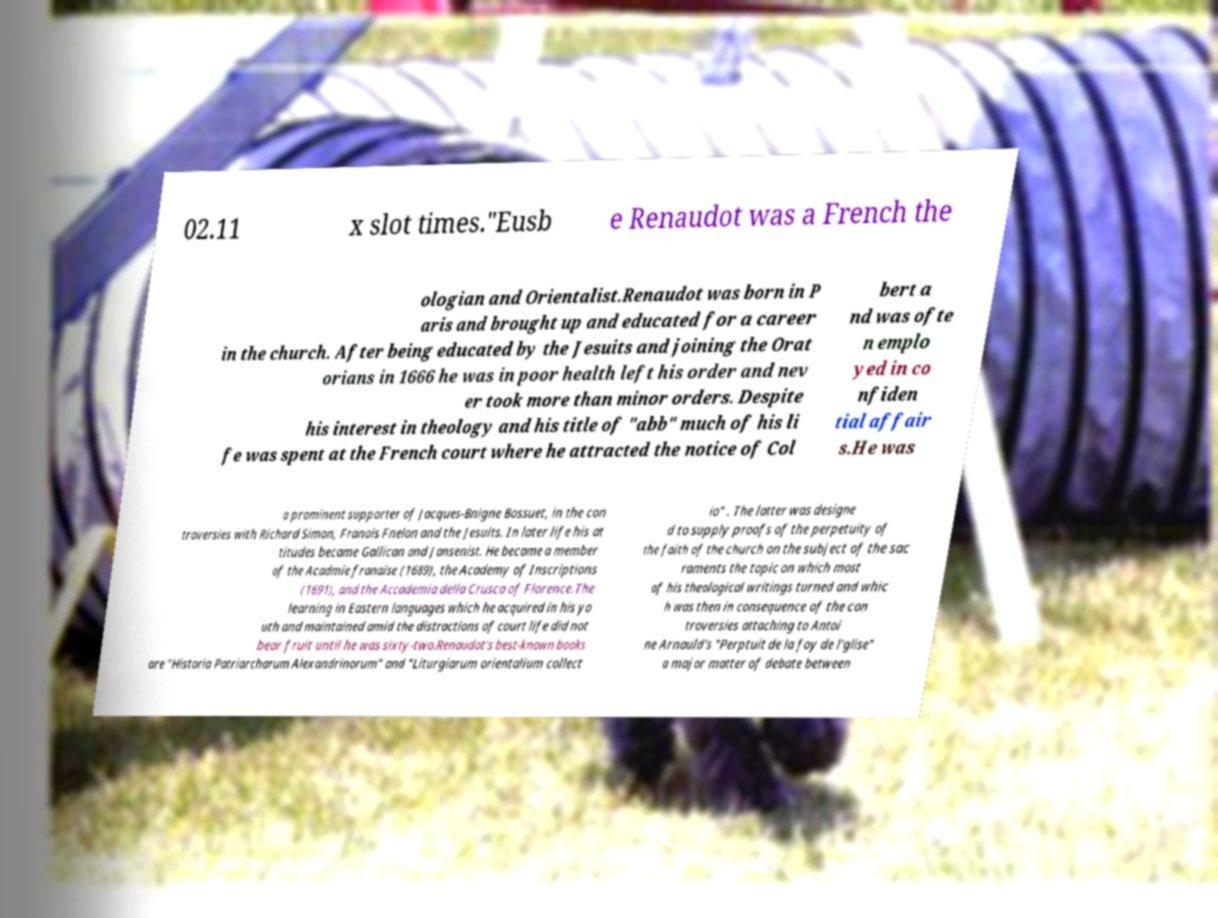For documentation purposes, I need the text within this image transcribed. Could you provide that? 02.11 x slot times."Eusb e Renaudot was a French the ologian and Orientalist.Renaudot was born in P aris and brought up and educated for a career in the church. After being educated by the Jesuits and joining the Orat orians in 1666 he was in poor health left his order and nev er took more than minor orders. Despite his interest in theology and his title of "abb" much of his li fe was spent at the French court where he attracted the notice of Col bert a nd was ofte n emplo yed in co nfiden tial affair s.He was a prominent supporter of Jacques-Bnigne Bossuet, in the con troversies with Richard Simon, Franois Fnelon and the Jesuits. In later life his at titudes became Gallican and Jansenist. He became a member of the Acadmie franaise (1689), the Academy of Inscriptions (1691), and the Accademia della Crusca of Florence.The learning in Eastern languages which he acquired in his yo uth and maintained amid the distractions of court life did not bear fruit until he was sixty-two.Renaudot's best-known books are "Historia Patriarcharum Alexandrinorum" and "Liturgiarum orientalium collect io" . The latter was designe d to supply proofs of the perpetuity of the faith of the church on the subject of the sac raments the topic on which most of his theological writings turned and whic h was then in consequence of the con troversies attaching to Antoi ne Arnauld's "Perptuit de la foy de l'glise" a major matter of debate between 